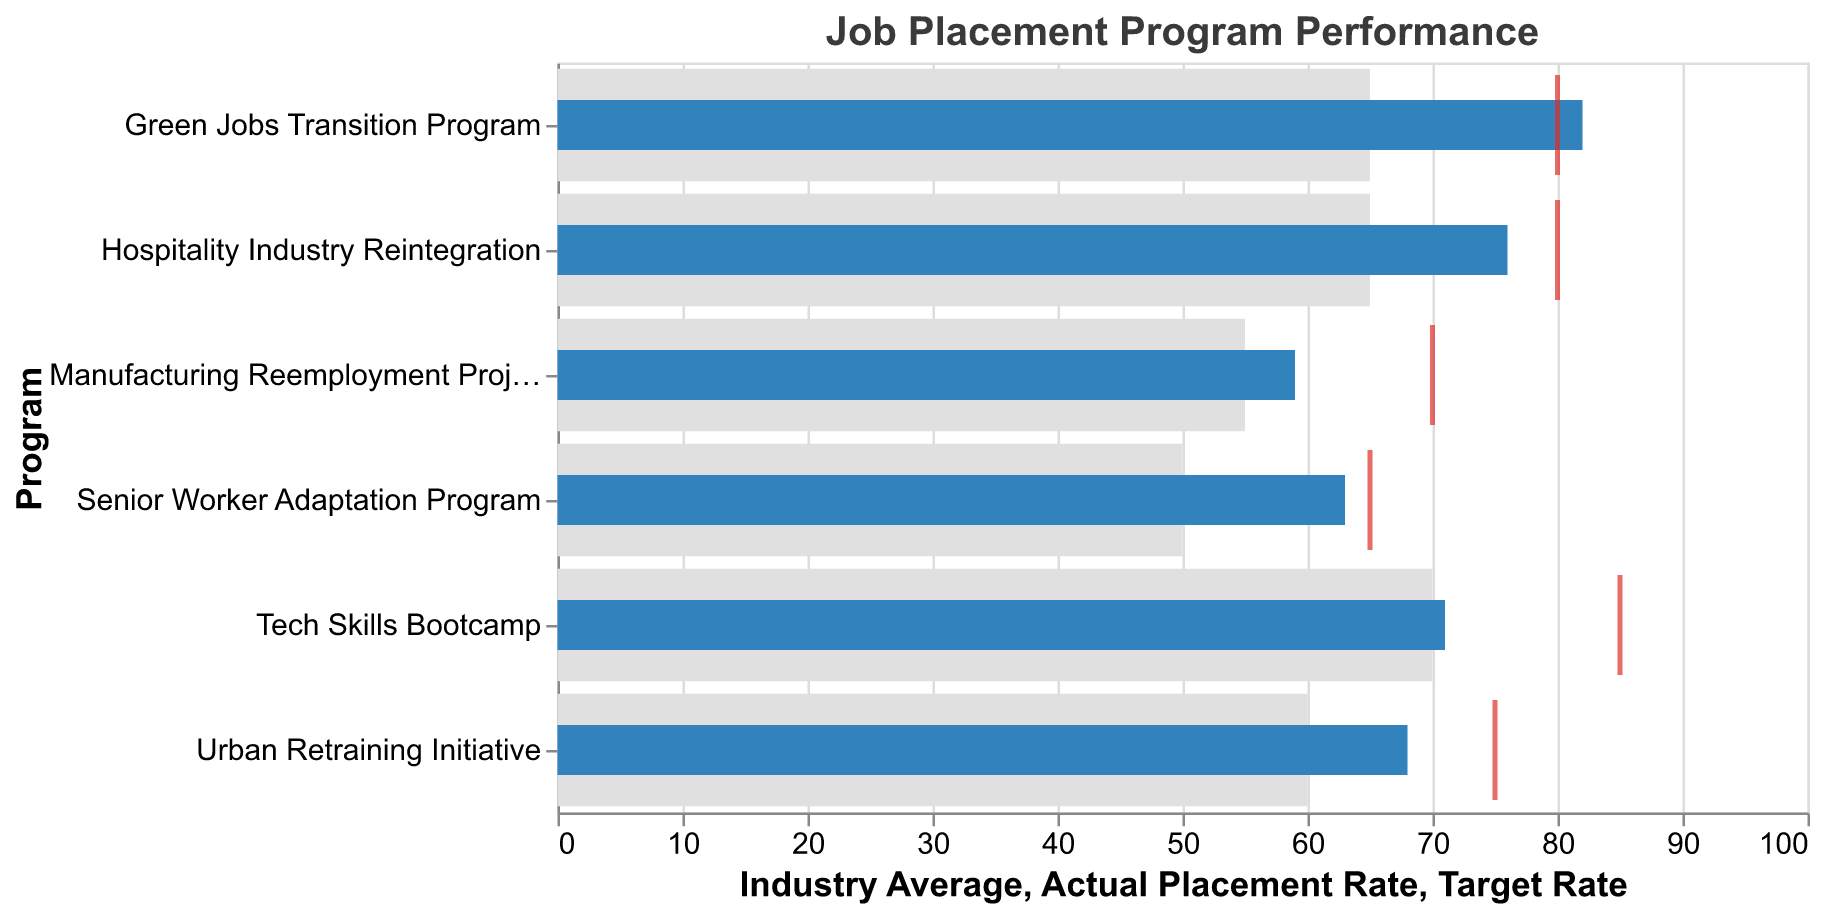What is the title of the chart? Look at the title text at the top of the chart; it shows the name or description of the chart. The title helps summarize the chart's contents.
Answer: Job Placement Program Performance How many job placement programs are listed in the chart? Count the unique program names on the y-axis. Each distinct name represents a different program.
Answer: 6 What color represents the actual placement rate bars? Observe the color used to fill the bars indicating the actual placement rate in the chart.
Answer: Blue What is the actual placement rate for the Green Jobs Transition Program? Look at the bar corresponding to the Green Jobs Transition Program and find the x-coordinate value of the blue bar.
Answer: 82 How many programs have an actual placement rate higher than the industry average? For each program, compare the height of the blue bar (actual placement rate) with the gray bar (industry average) and count how many exceed the industry average.
Answer: 5 Which program has the lowest actual placement rate? Identify the bar with the smallest blue bar value by comparing the lengths of all blue bars.
Answer: Manufacturing Reemployment Project How much higher is the actual placement rate compared to the industry average for the Hospitality Industry Reintegration program? Subtract the industry average (gray bar) from the actual placement rate (blue bar) for the Hospitality Industry Reintegration program. Calculation: 76 - 65 = 11
Answer: 11 Which program has surpassed its target rate? Compare the blue bars (actual placement rates) with the red ticks (target rates) and identify which program's blue bar exceeds its red tick.
Answer: Green Jobs Transition Program What is the difference between the target rate and the actual placement rate in the Tech Skills Bootcamp program? Subtract the actual placement rate (blue bar) from the target rate (red tick) for the Tech Skills Bootcamp. Calculation: 85 - 71 = 14
Answer: 14 How does the Urban Retraining Initiative's actual placement rate compare to its target rate? Look at both the blue bar and the red tick for the Urban Retraining Initiative to see if the blue bar reaches the red tick or falls short. The blue bar does not reach the red tick, indicating it is below the target rate.
Answer: Below target 